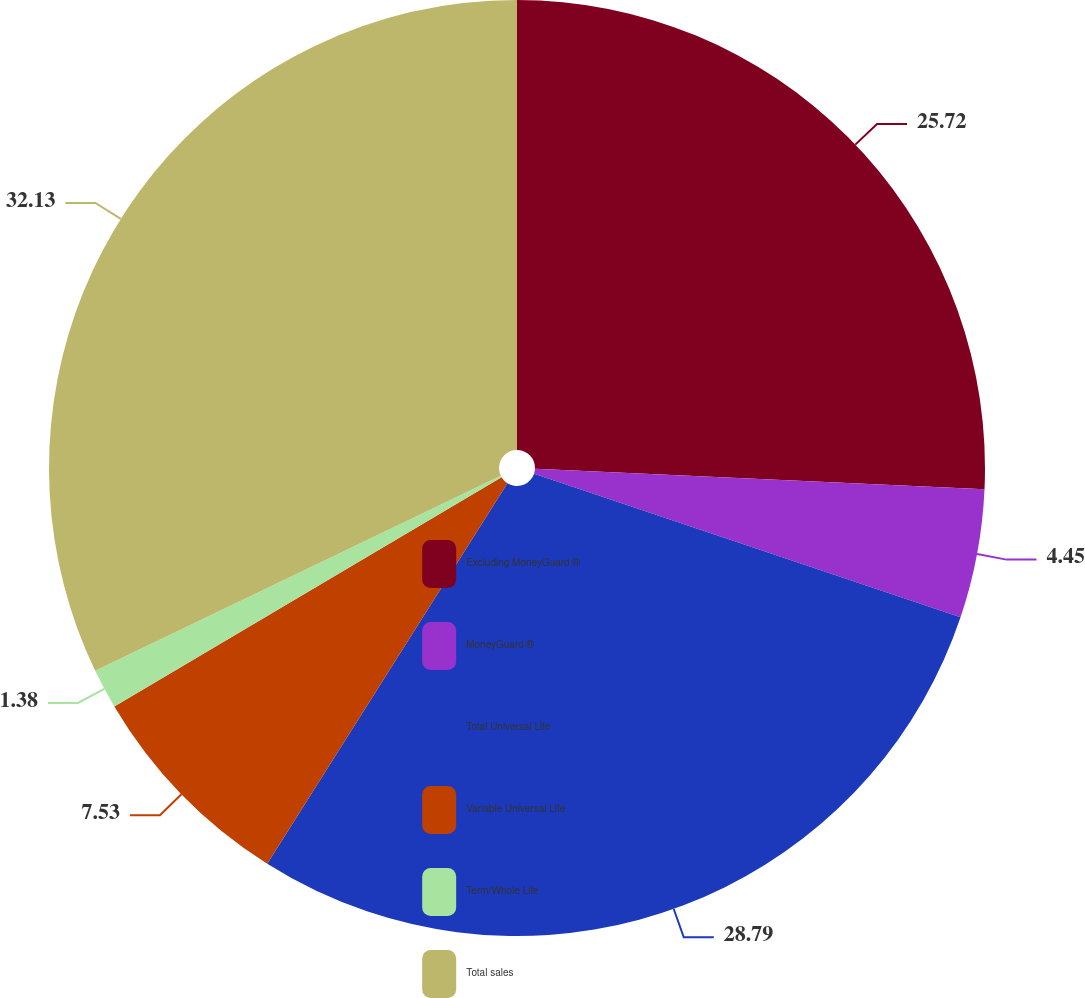Convert chart to OTSL. <chart><loc_0><loc_0><loc_500><loc_500><pie_chart><fcel>Excluding MoneyGuard ®<fcel>MoneyGuard ®<fcel>Total Universal Life<fcel>Variable Universal Life<fcel>Term/Whole Life<fcel>Total sales<nl><fcel>25.72%<fcel>4.45%<fcel>28.79%<fcel>7.53%<fcel>1.38%<fcel>32.13%<nl></chart> 